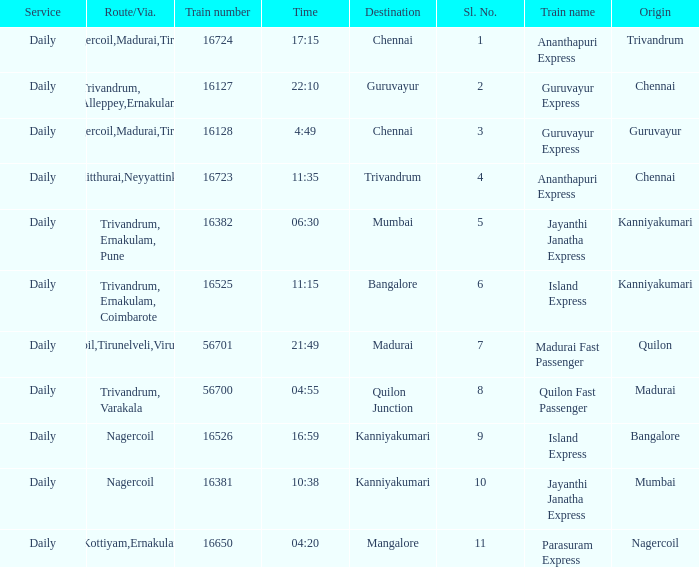What is the train number when the time is 10:38? 16381.0. 